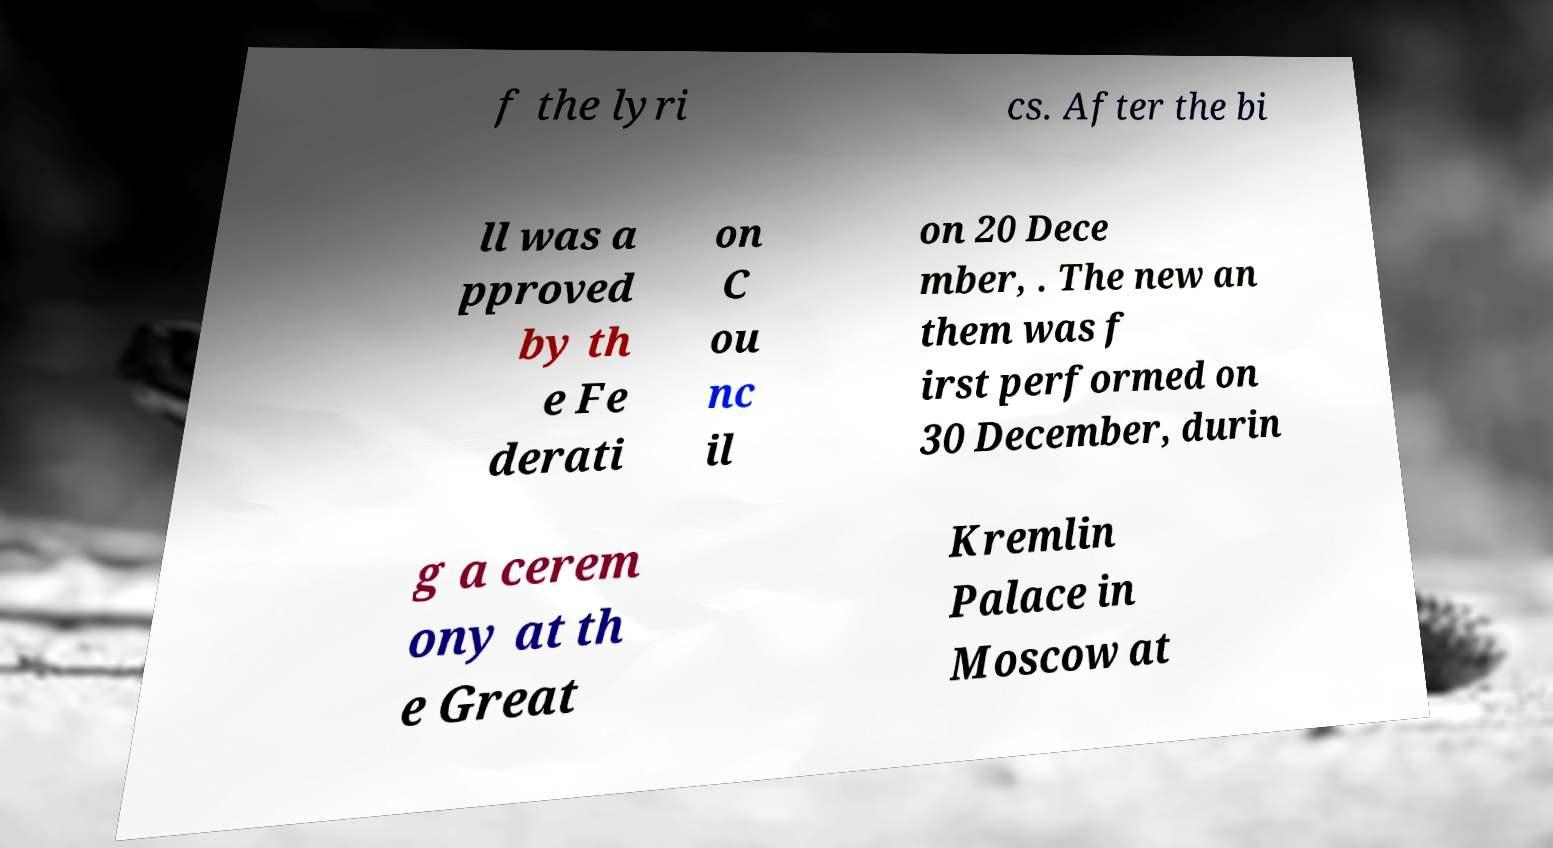I need the written content from this picture converted into text. Can you do that? f the lyri cs. After the bi ll was a pproved by th e Fe derati on C ou nc il on 20 Dece mber, . The new an them was f irst performed on 30 December, durin g a cerem ony at th e Great Kremlin Palace in Moscow at 